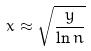<formula> <loc_0><loc_0><loc_500><loc_500>x \approx \sqrt { \frac { y } { \ln n } }</formula> 